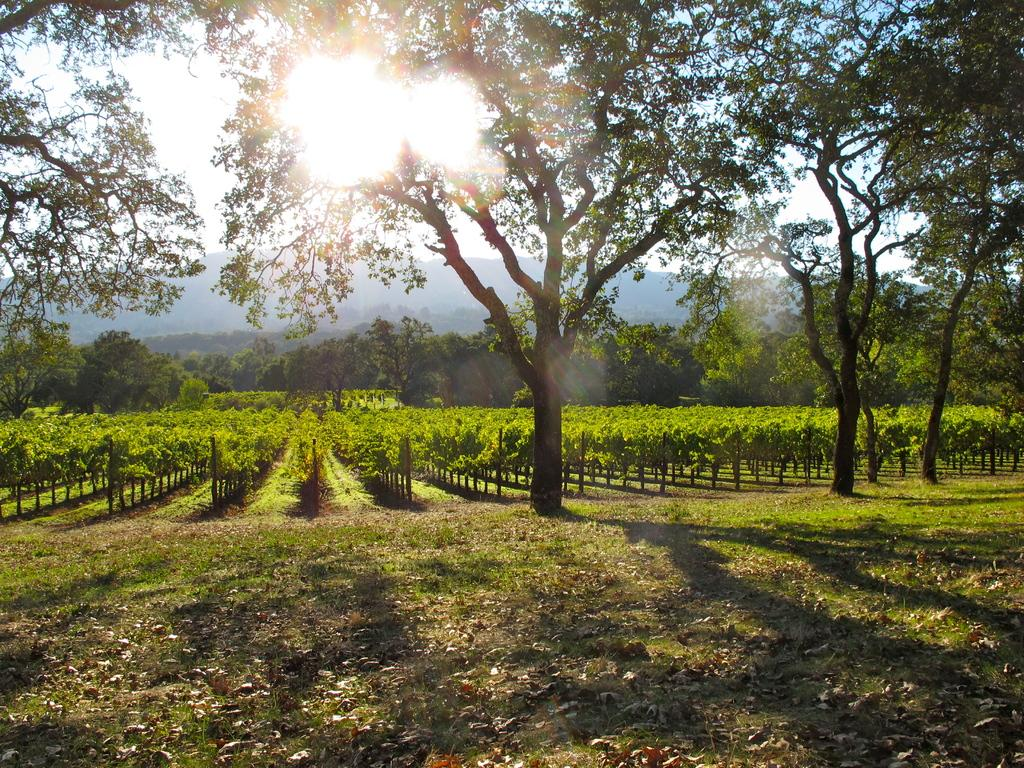What type of vegetation can be seen in the image? There are trees and plants in the image. What color are the trees and plants in the image? The trees and plants are in green color. What is visible in the background of the image? The sky is visible in the background of the image. What color is the sky in the image? The sky is in white color. How much do the trees weigh in the image? The weight of the trees cannot be determined from the image, as it is a two-dimensional representation and does not provide information about the trees' mass or size. 